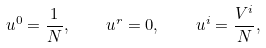Convert formula to latex. <formula><loc_0><loc_0><loc_500><loc_500>u ^ { 0 } = \frac { 1 } { N } , \quad u ^ { r } = 0 , \quad u ^ { i } = \frac { V ^ { i } } { N } ,</formula> 